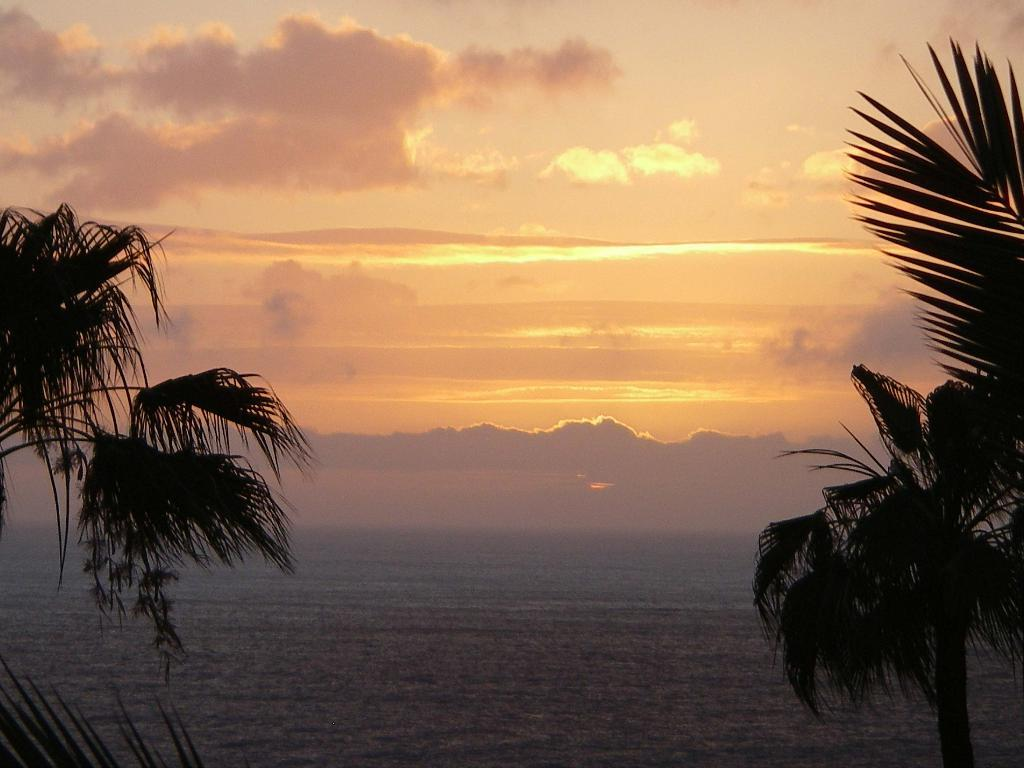How many trees can be seen in the picture? There are two trees in the picture, one on each side. What else can be seen in the image besides the trees? Water is visible in the image. What is visible in the background of the image? There is a sky in the background of the image. What can be observed in the sky? Clouds are present in the sky. What is the source of light in the image? Sunshine is visible in the image. How many loaves of bread are floating in the water in the image? There are no loaves of bread present in the image; it features two trees, water, a sky, clouds, and sunshine. 